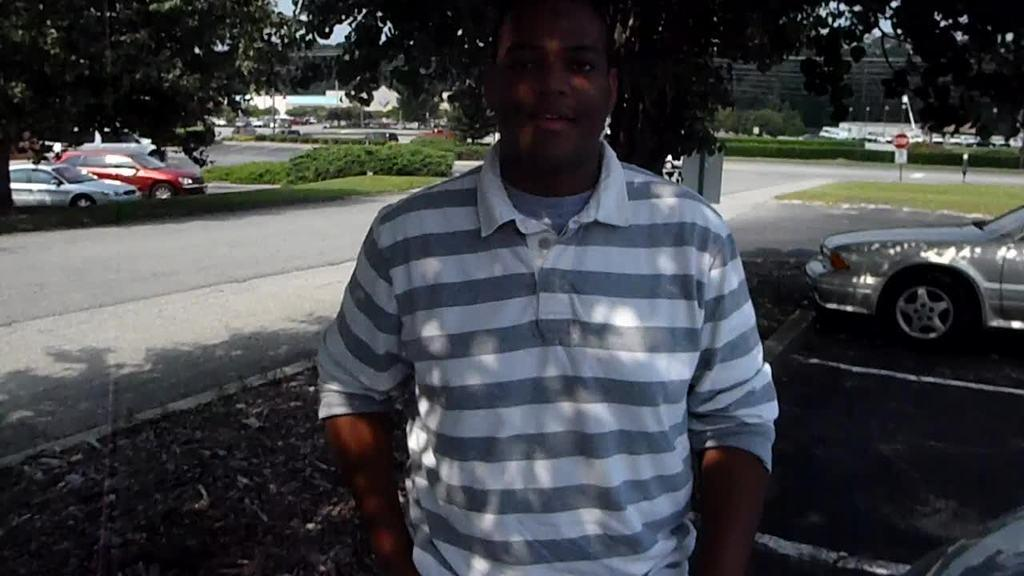What is the main subject in the front of the image? There is a man standing in the front of the image. What can be seen in the background of the image? In the background of the image, there are plants, cars, grass, boards, and buildings. Can you describe the ground in the image? The ground in the image is covered with grass. What type of creature is the man interacting with in the image? There is no creature present in the image; the man is standing alone. What channel is the man watching on the boards in the background? There is no television or channel visible in the image; the boards are likely unrelated to any broadcasting. 